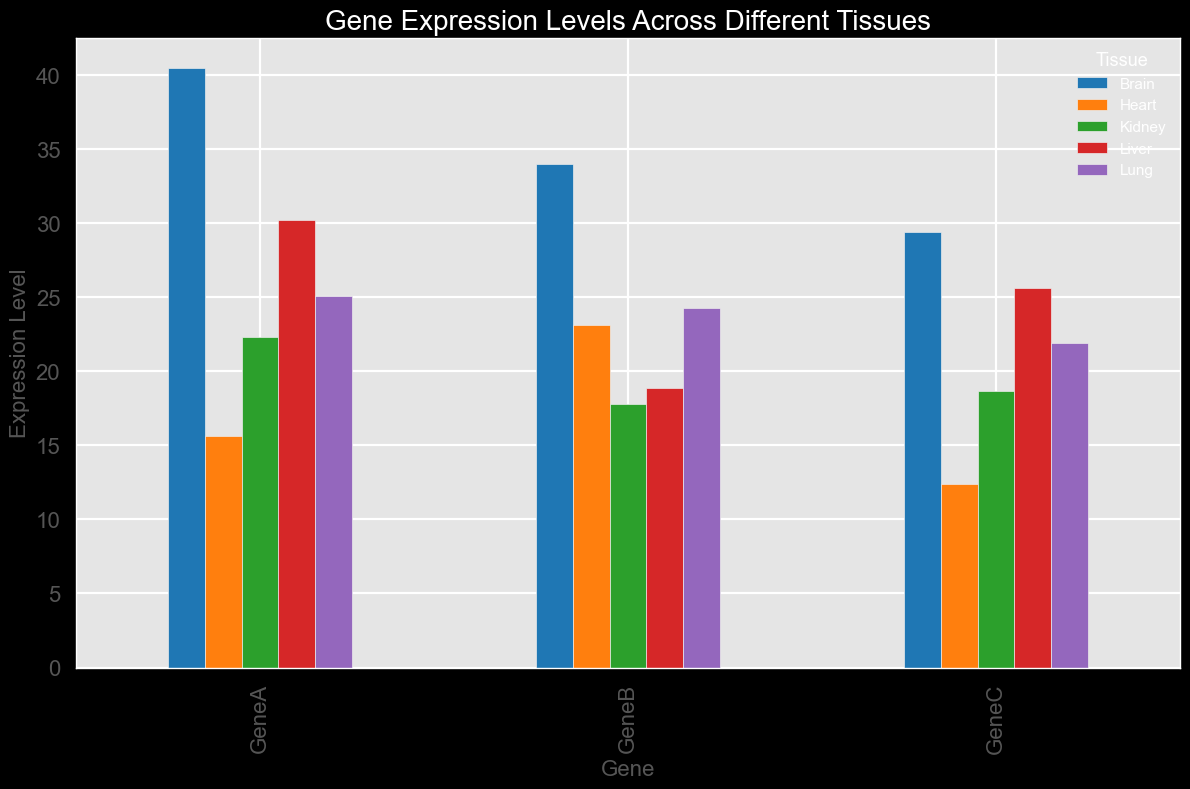What's the gene with the highest expression level overall, and what is that level? By observing the bar heights across all genes and tissues, the tallest bar represents the highest expression level. In this case, the expression level for GeneA in the Brain (40.5) is the highest overall.
Answer: GeneA in the Brain, 40.5 For GeneB, which tissue shows the lowest expression level and what is that level? Look at the bars representing GeneB in each tissue and identify the shortest one. The bar for GeneB in the Kidney is the shortest one, indicating the lowest expression level. The level is 17.8.
Answer: Kidney, 17.8 How much higher is the expression level of GeneA in the Brain compared to GeneA in the Heart? Find the expression levels of GeneA in both the Brain and the Heart. Subtract the Heart's level (15.6) from the Brain's level (40.5). This gives the difference.
Answer: 40.5 - 15.6 = 24.9 Which gene shows the smallest variation in expression levels across the tissues? Observe the bars for each gene across the tissues. GeneC has the smallest range, with values not varying greatly (12.4 in Heart, 25.6 in Liver, 29.4 in Brain, 18.7 in Kidney, 21.9 in Lung).
Answer: GeneC What is the total expression level of GeneC across all tissues? Sum the expression levels of GeneC in each tissue: 12.4 + 25.6 + 29.4 + 18.7 + 21.9. Add these values together to get the total.
Answer: 107 Compare the expression levels of GeneA in Liver and Lung. Which one is higher and by how much? Check the expression levels of GeneA in Liver (30.2) and Lung (25.1). Then, calculate the difference: 30.2 - 25.1.
Answer: Liver, 5.1 What is the average expression level of GeneB across all tissues? Sum up the expression levels of GeneB in each tissue (23.1 + 18.9 + 34.0 + 17.8 + 24.3), then divide by the number of tissues (5): (23.1 + 18.9 + 34.0 + 17.8 + 24.3) / 5.
Answer: 23.62 Is the expression level of GeneC in the kidney higher or lower than the overall average expression level of GeneC? Calculate the average level of GeneC: (12.4 + 25.6 + 29.4 + 18.7 + 21.9) / 5 = 21.6. Compare this to the expression level of GeneC in the kidney (18.7).
Answer: Lower, 18.7 < 21.6 Identify which tissue has the most uniformly expressed genes. Examine how close the expression levels for all genes within a tissue are. Brain has relatively high and uniformly distributed values (40.5, 34.0, 29.4) compared to other tissues.
Answer: Brain 